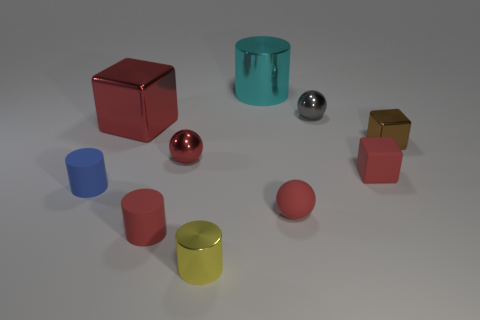How many red cubes must be subtracted to get 1 red cubes? 1 Subtract all small red spheres. How many spheres are left? 1 Subtract all red balls. How many balls are left? 1 Subtract 4 cylinders. How many cylinders are left? 0 Subtract all balls. How many objects are left? 7 Subtract all red balls. How many green cylinders are left? 0 Add 9 small red rubber blocks. How many small red rubber blocks are left? 10 Add 6 big cyan metal things. How many big cyan metal things exist? 7 Subtract 0 yellow cubes. How many objects are left? 10 Subtract all blue blocks. Subtract all gray balls. How many blocks are left? 3 